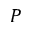Convert formula to latex. <formula><loc_0><loc_0><loc_500><loc_500>P</formula> 